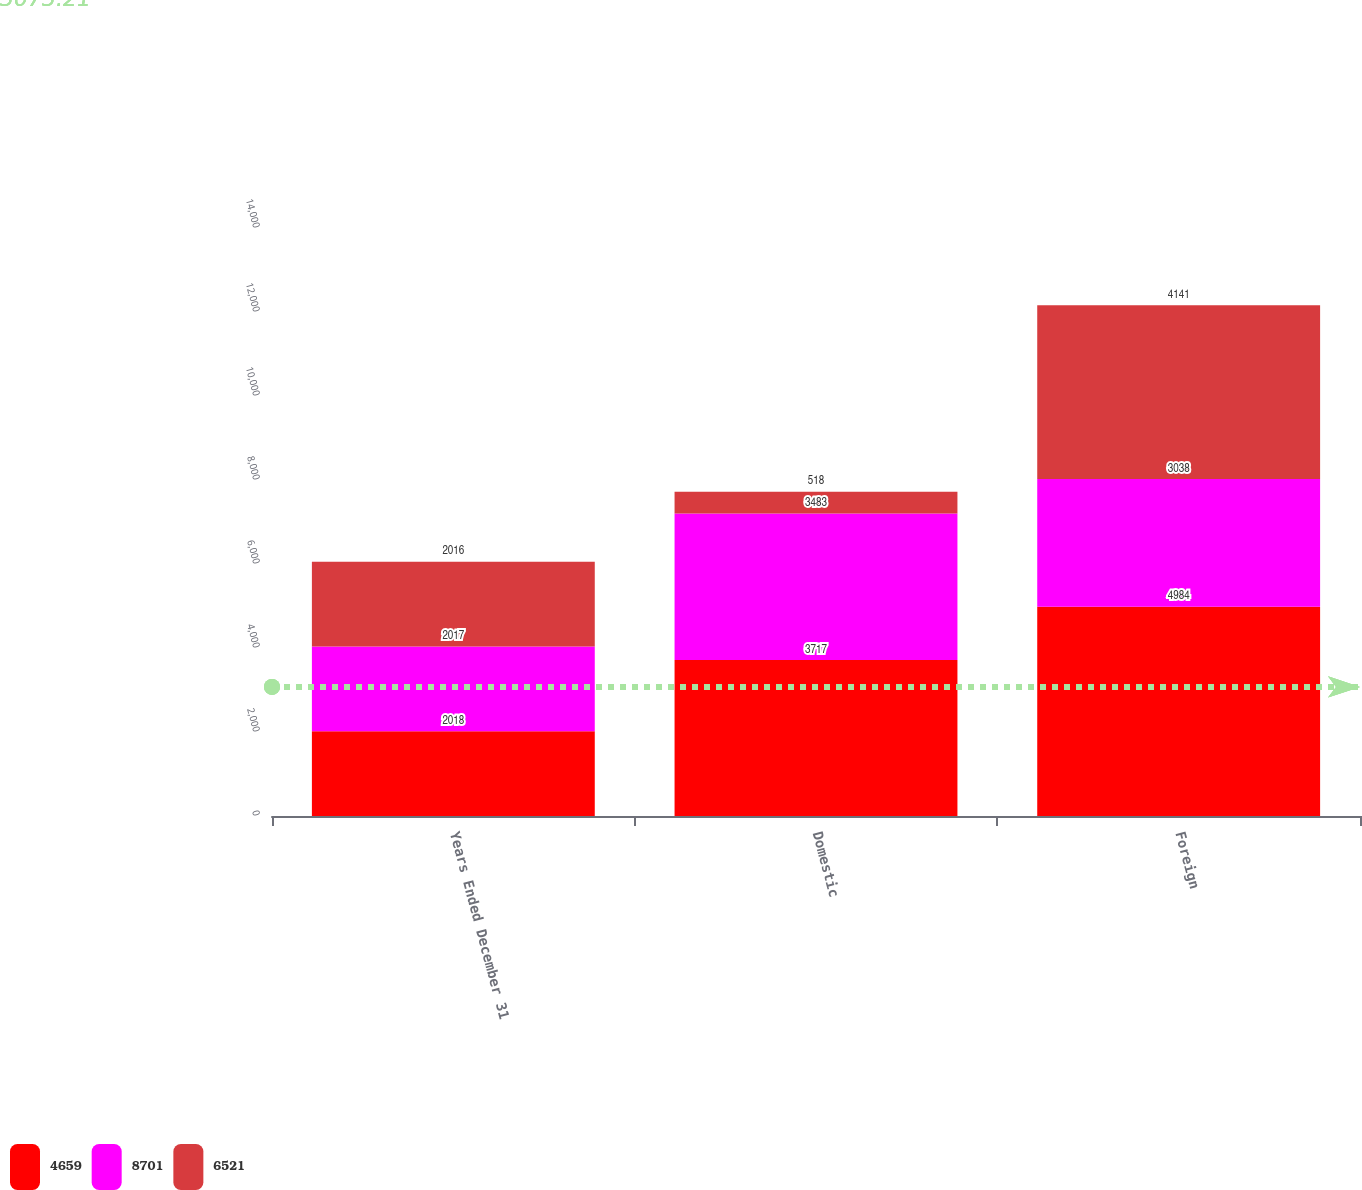<chart> <loc_0><loc_0><loc_500><loc_500><stacked_bar_chart><ecel><fcel>Years Ended December 31<fcel>Domestic<fcel>Foreign<nl><fcel>4659<fcel>2018<fcel>3717<fcel>4984<nl><fcel>8701<fcel>2017<fcel>3483<fcel>3038<nl><fcel>6521<fcel>2016<fcel>518<fcel>4141<nl></chart> 